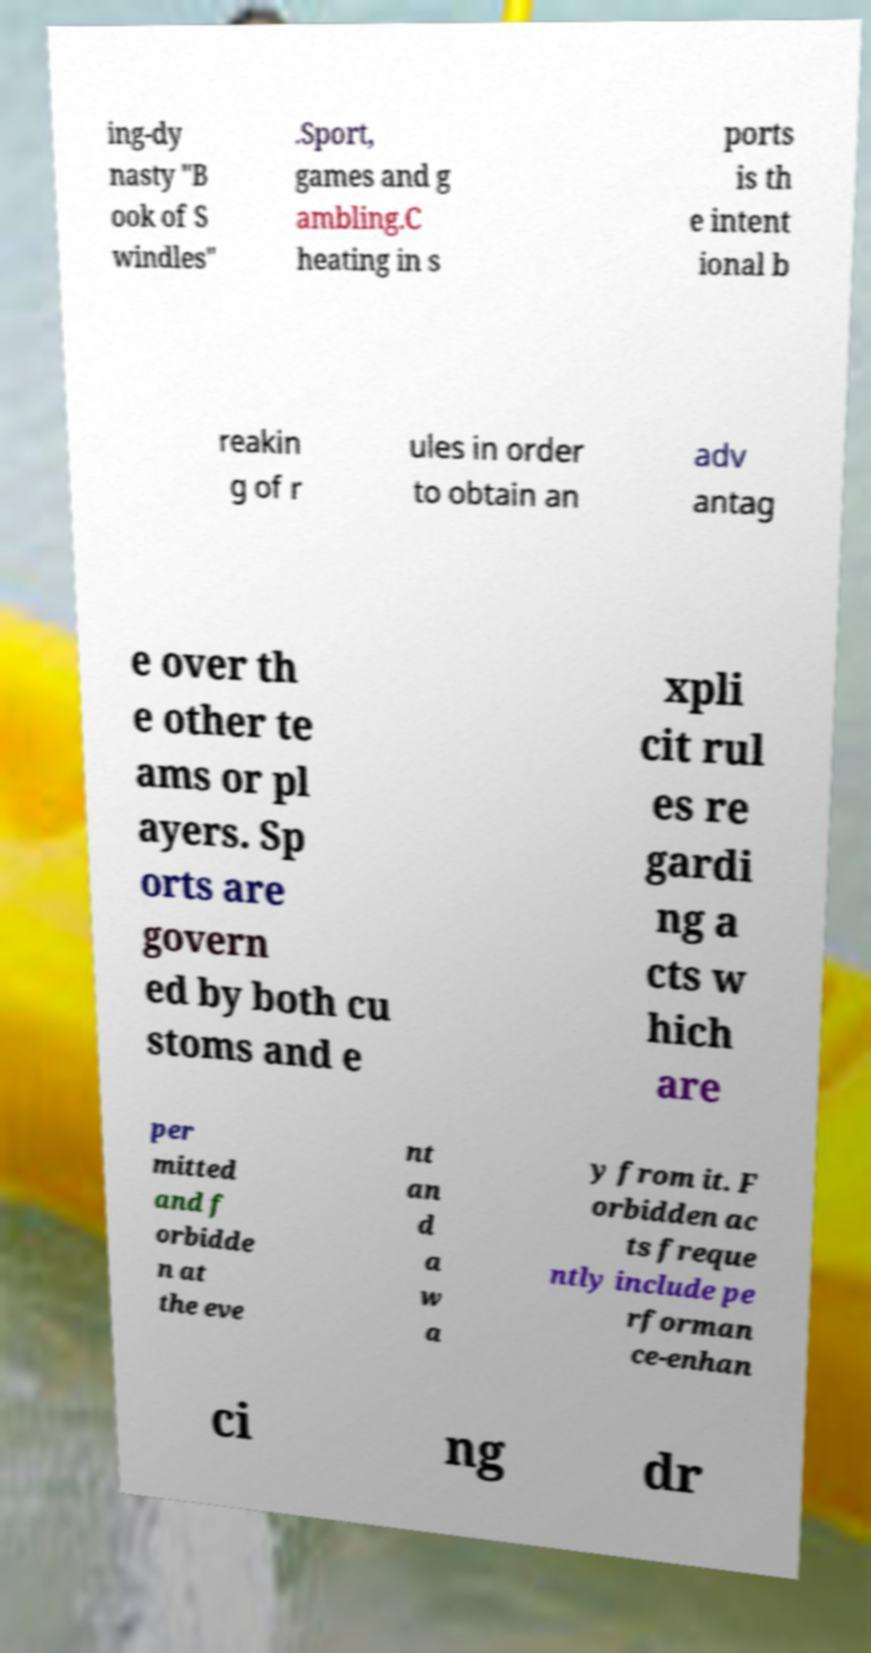What messages or text are displayed in this image? I need them in a readable, typed format. ing-dy nasty "B ook of S windles" .Sport, games and g ambling.C heating in s ports is th e intent ional b reakin g of r ules in order to obtain an adv antag e over th e other te ams or pl ayers. Sp orts are govern ed by both cu stoms and e xpli cit rul es re gardi ng a cts w hich are per mitted and f orbidde n at the eve nt an d a w a y from it. F orbidden ac ts freque ntly include pe rforman ce-enhan ci ng dr 